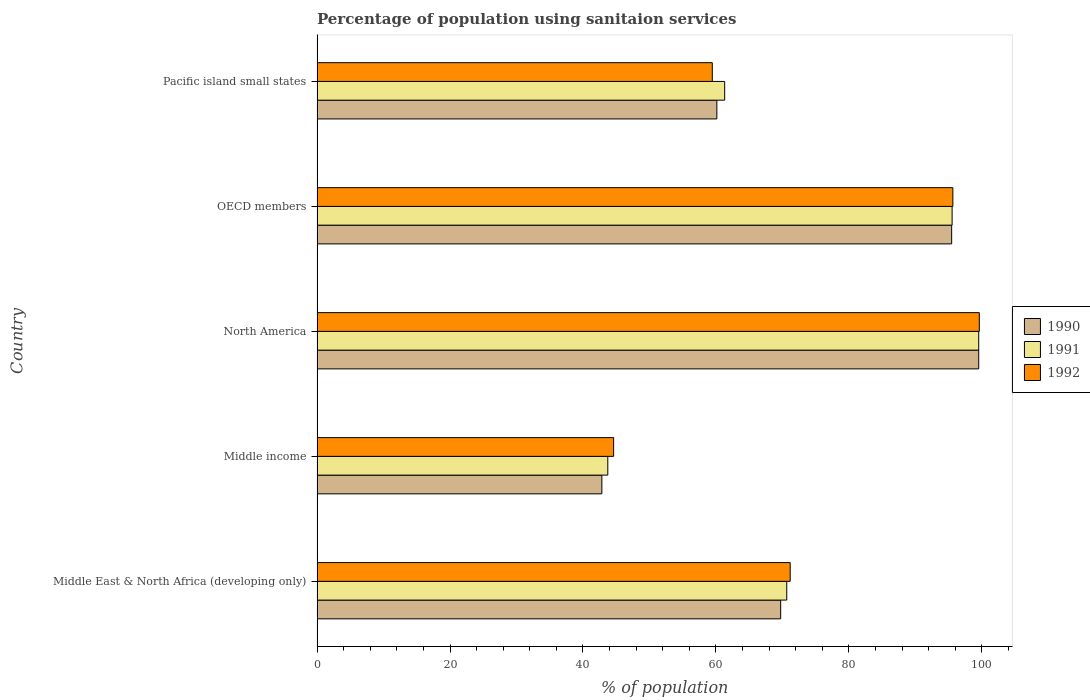How many different coloured bars are there?
Make the answer very short. 3. How many groups of bars are there?
Give a very brief answer. 5. Are the number of bars per tick equal to the number of legend labels?
Make the answer very short. Yes. How many bars are there on the 4th tick from the top?
Keep it short and to the point. 3. How many bars are there on the 4th tick from the bottom?
Your answer should be very brief. 3. What is the label of the 5th group of bars from the top?
Your response must be concise. Middle East & North Africa (developing only). In how many cases, is the number of bars for a given country not equal to the number of legend labels?
Provide a short and direct response. 0. What is the percentage of population using sanitaion services in 1991 in Middle East & North Africa (developing only)?
Your answer should be very brief. 70.65. Across all countries, what is the maximum percentage of population using sanitaion services in 1991?
Your answer should be very brief. 99.53. Across all countries, what is the minimum percentage of population using sanitaion services in 1990?
Make the answer very short. 42.84. In which country was the percentage of population using sanitaion services in 1991 maximum?
Give a very brief answer. North America. What is the total percentage of population using sanitaion services in 1992 in the graph?
Keep it short and to the point. 370.5. What is the difference between the percentage of population using sanitaion services in 1990 in Middle East & North Africa (developing only) and that in Middle income?
Offer a very short reply. 26.9. What is the difference between the percentage of population using sanitaion services in 1991 in Middle income and the percentage of population using sanitaion services in 1992 in Middle East & North Africa (developing only)?
Ensure brevity in your answer.  -27.43. What is the average percentage of population using sanitaion services in 1990 per country?
Your response must be concise. 73.54. What is the difference between the percentage of population using sanitaion services in 1992 and percentage of population using sanitaion services in 1991 in OECD members?
Provide a succinct answer. 0.11. What is the ratio of the percentage of population using sanitaion services in 1992 in Middle East & North Africa (developing only) to that in Pacific island small states?
Your response must be concise. 1.2. Is the percentage of population using sanitaion services in 1990 in OECD members less than that in Pacific island small states?
Ensure brevity in your answer.  No. Is the difference between the percentage of population using sanitaion services in 1992 in Middle income and Pacific island small states greater than the difference between the percentage of population using sanitaion services in 1991 in Middle income and Pacific island small states?
Your response must be concise. Yes. What is the difference between the highest and the second highest percentage of population using sanitaion services in 1990?
Provide a succinct answer. 4.07. What is the difference between the highest and the lowest percentage of population using sanitaion services in 1992?
Your response must be concise. 55.01. In how many countries, is the percentage of population using sanitaion services in 1992 greater than the average percentage of population using sanitaion services in 1992 taken over all countries?
Make the answer very short. 2. Is the sum of the percentage of population using sanitaion services in 1990 in Middle income and OECD members greater than the maximum percentage of population using sanitaion services in 1991 across all countries?
Provide a short and direct response. Yes. What does the 3rd bar from the top in Middle East & North Africa (developing only) represents?
Keep it short and to the point. 1990. What does the 1st bar from the bottom in OECD members represents?
Make the answer very short. 1990. Is it the case that in every country, the sum of the percentage of population using sanitaion services in 1992 and percentage of population using sanitaion services in 1991 is greater than the percentage of population using sanitaion services in 1990?
Give a very brief answer. Yes. How many bars are there?
Provide a short and direct response. 15. Are all the bars in the graph horizontal?
Provide a short and direct response. Yes. How many countries are there in the graph?
Your response must be concise. 5. What is the difference between two consecutive major ticks on the X-axis?
Your answer should be very brief. 20. Does the graph contain grids?
Provide a succinct answer. No. How are the legend labels stacked?
Provide a succinct answer. Vertical. What is the title of the graph?
Your response must be concise. Percentage of population using sanitaion services. What is the label or title of the X-axis?
Keep it short and to the point. % of population. What is the label or title of the Y-axis?
Your answer should be compact. Country. What is the % of population of 1990 in Middle East & North Africa (developing only)?
Ensure brevity in your answer.  69.74. What is the % of population in 1991 in Middle East & North Africa (developing only)?
Provide a succinct answer. 70.65. What is the % of population of 1992 in Middle East & North Africa (developing only)?
Keep it short and to the point. 71.17. What is the % of population of 1990 in Middle income?
Your answer should be very brief. 42.84. What is the % of population in 1991 in Middle income?
Keep it short and to the point. 43.74. What is the % of population of 1992 in Middle income?
Make the answer very short. 44.61. What is the % of population in 1990 in North America?
Your answer should be compact. 99.53. What is the % of population of 1991 in North America?
Keep it short and to the point. 99.53. What is the % of population of 1992 in North America?
Keep it short and to the point. 99.62. What is the % of population of 1990 in OECD members?
Keep it short and to the point. 95.46. What is the % of population in 1991 in OECD members?
Your answer should be very brief. 95.53. What is the % of population of 1992 in OECD members?
Offer a terse response. 95.64. What is the % of population of 1990 in Pacific island small states?
Your answer should be very brief. 60.14. What is the % of population of 1991 in Pacific island small states?
Provide a succinct answer. 61.32. What is the % of population of 1992 in Pacific island small states?
Your answer should be compact. 59.45. Across all countries, what is the maximum % of population in 1990?
Keep it short and to the point. 99.53. Across all countries, what is the maximum % of population of 1991?
Give a very brief answer. 99.53. Across all countries, what is the maximum % of population of 1992?
Ensure brevity in your answer.  99.62. Across all countries, what is the minimum % of population in 1990?
Offer a terse response. 42.84. Across all countries, what is the minimum % of population in 1991?
Give a very brief answer. 43.74. Across all countries, what is the minimum % of population of 1992?
Make the answer very short. 44.61. What is the total % of population in 1990 in the graph?
Your answer should be very brief. 367.71. What is the total % of population of 1991 in the graph?
Make the answer very short. 370.76. What is the total % of population of 1992 in the graph?
Provide a short and direct response. 370.5. What is the difference between the % of population of 1990 in Middle East & North Africa (developing only) and that in Middle income?
Make the answer very short. 26.9. What is the difference between the % of population of 1991 in Middle East & North Africa (developing only) and that in Middle income?
Ensure brevity in your answer.  26.92. What is the difference between the % of population in 1992 in Middle East & North Africa (developing only) and that in Middle income?
Your response must be concise. 26.56. What is the difference between the % of population in 1990 in Middle East & North Africa (developing only) and that in North America?
Your answer should be compact. -29.79. What is the difference between the % of population in 1991 in Middle East & North Africa (developing only) and that in North America?
Provide a succinct answer. -28.88. What is the difference between the % of population of 1992 in Middle East & North Africa (developing only) and that in North America?
Offer a terse response. -28.45. What is the difference between the % of population in 1990 in Middle East & North Africa (developing only) and that in OECD members?
Your answer should be compact. -25.72. What is the difference between the % of population of 1991 in Middle East & North Africa (developing only) and that in OECD members?
Provide a short and direct response. -24.87. What is the difference between the % of population of 1992 in Middle East & North Africa (developing only) and that in OECD members?
Ensure brevity in your answer.  -24.47. What is the difference between the % of population of 1990 in Middle East & North Africa (developing only) and that in Pacific island small states?
Ensure brevity in your answer.  9.6. What is the difference between the % of population in 1991 in Middle East & North Africa (developing only) and that in Pacific island small states?
Ensure brevity in your answer.  9.34. What is the difference between the % of population of 1992 in Middle East & North Africa (developing only) and that in Pacific island small states?
Ensure brevity in your answer.  11.72. What is the difference between the % of population in 1990 in Middle income and that in North America?
Offer a very short reply. -56.69. What is the difference between the % of population of 1991 in Middle income and that in North America?
Your response must be concise. -55.79. What is the difference between the % of population of 1992 in Middle income and that in North America?
Your response must be concise. -55.01. What is the difference between the % of population in 1990 in Middle income and that in OECD members?
Give a very brief answer. -52.62. What is the difference between the % of population of 1991 in Middle income and that in OECD members?
Offer a terse response. -51.79. What is the difference between the % of population of 1992 in Middle income and that in OECD members?
Your response must be concise. -51.03. What is the difference between the % of population in 1990 in Middle income and that in Pacific island small states?
Provide a succinct answer. -17.3. What is the difference between the % of population of 1991 in Middle income and that in Pacific island small states?
Give a very brief answer. -17.58. What is the difference between the % of population in 1992 in Middle income and that in Pacific island small states?
Give a very brief answer. -14.84. What is the difference between the % of population in 1990 in North America and that in OECD members?
Provide a succinct answer. 4.07. What is the difference between the % of population of 1991 in North America and that in OECD members?
Offer a very short reply. 4. What is the difference between the % of population of 1992 in North America and that in OECD members?
Offer a terse response. 3.98. What is the difference between the % of population in 1990 in North America and that in Pacific island small states?
Your answer should be compact. 39.39. What is the difference between the % of population in 1991 in North America and that in Pacific island small states?
Your response must be concise. 38.21. What is the difference between the % of population in 1992 in North America and that in Pacific island small states?
Make the answer very short. 40.17. What is the difference between the % of population in 1990 in OECD members and that in Pacific island small states?
Keep it short and to the point. 35.32. What is the difference between the % of population of 1991 in OECD members and that in Pacific island small states?
Your response must be concise. 34.21. What is the difference between the % of population in 1992 in OECD members and that in Pacific island small states?
Your response must be concise. 36.19. What is the difference between the % of population in 1990 in Middle East & North Africa (developing only) and the % of population in 1991 in Middle income?
Make the answer very short. 26. What is the difference between the % of population in 1990 in Middle East & North Africa (developing only) and the % of population in 1992 in Middle income?
Provide a succinct answer. 25.13. What is the difference between the % of population in 1991 in Middle East & North Africa (developing only) and the % of population in 1992 in Middle income?
Provide a short and direct response. 26.04. What is the difference between the % of population of 1990 in Middle East & North Africa (developing only) and the % of population of 1991 in North America?
Keep it short and to the point. -29.79. What is the difference between the % of population of 1990 in Middle East & North Africa (developing only) and the % of population of 1992 in North America?
Provide a short and direct response. -29.88. What is the difference between the % of population in 1991 in Middle East & North Africa (developing only) and the % of population in 1992 in North America?
Your answer should be very brief. -28.97. What is the difference between the % of population in 1990 in Middle East & North Africa (developing only) and the % of population in 1991 in OECD members?
Your answer should be compact. -25.79. What is the difference between the % of population of 1990 in Middle East & North Africa (developing only) and the % of population of 1992 in OECD members?
Your response must be concise. -25.9. What is the difference between the % of population in 1991 in Middle East & North Africa (developing only) and the % of population in 1992 in OECD members?
Provide a succinct answer. -24.99. What is the difference between the % of population of 1990 in Middle East & North Africa (developing only) and the % of population of 1991 in Pacific island small states?
Give a very brief answer. 8.42. What is the difference between the % of population in 1990 in Middle East & North Africa (developing only) and the % of population in 1992 in Pacific island small states?
Provide a succinct answer. 10.29. What is the difference between the % of population in 1991 in Middle East & North Africa (developing only) and the % of population in 1992 in Pacific island small states?
Your response must be concise. 11.2. What is the difference between the % of population in 1990 in Middle income and the % of population in 1991 in North America?
Provide a short and direct response. -56.69. What is the difference between the % of population in 1990 in Middle income and the % of population in 1992 in North America?
Your answer should be very brief. -56.78. What is the difference between the % of population in 1991 in Middle income and the % of population in 1992 in North America?
Make the answer very short. -55.88. What is the difference between the % of population in 1990 in Middle income and the % of population in 1991 in OECD members?
Make the answer very short. -52.69. What is the difference between the % of population of 1990 in Middle income and the % of population of 1992 in OECD members?
Your answer should be compact. -52.8. What is the difference between the % of population of 1991 in Middle income and the % of population of 1992 in OECD members?
Your response must be concise. -51.9. What is the difference between the % of population of 1990 in Middle income and the % of population of 1991 in Pacific island small states?
Ensure brevity in your answer.  -18.47. What is the difference between the % of population in 1990 in Middle income and the % of population in 1992 in Pacific island small states?
Your answer should be compact. -16.61. What is the difference between the % of population of 1991 in Middle income and the % of population of 1992 in Pacific island small states?
Give a very brief answer. -15.72. What is the difference between the % of population of 1990 in North America and the % of population of 1991 in OECD members?
Provide a succinct answer. 4. What is the difference between the % of population of 1990 in North America and the % of population of 1992 in OECD members?
Offer a very short reply. 3.89. What is the difference between the % of population in 1991 in North America and the % of population in 1992 in OECD members?
Offer a terse response. 3.89. What is the difference between the % of population in 1990 in North America and the % of population in 1991 in Pacific island small states?
Keep it short and to the point. 38.21. What is the difference between the % of population of 1990 in North America and the % of population of 1992 in Pacific island small states?
Ensure brevity in your answer.  40.08. What is the difference between the % of population in 1991 in North America and the % of population in 1992 in Pacific island small states?
Your response must be concise. 40.08. What is the difference between the % of population of 1990 in OECD members and the % of population of 1991 in Pacific island small states?
Your answer should be very brief. 34.14. What is the difference between the % of population in 1990 in OECD members and the % of population in 1992 in Pacific island small states?
Your answer should be compact. 36.01. What is the difference between the % of population in 1991 in OECD members and the % of population in 1992 in Pacific island small states?
Your answer should be compact. 36.07. What is the average % of population in 1990 per country?
Make the answer very short. 73.54. What is the average % of population in 1991 per country?
Offer a terse response. 74.15. What is the average % of population in 1992 per country?
Give a very brief answer. 74.1. What is the difference between the % of population of 1990 and % of population of 1991 in Middle East & North Africa (developing only)?
Your answer should be very brief. -0.91. What is the difference between the % of population of 1990 and % of population of 1992 in Middle East & North Africa (developing only)?
Your answer should be very brief. -1.43. What is the difference between the % of population in 1991 and % of population in 1992 in Middle East & North Africa (developing only)?
Provide a short and direct response. -0.52. What is the difference between the % of population in 1990 and % of population in 1991 in Middle income?
Offer a very short reply. -0.89. What is the difference between the % of population in 1990 and % of population in 1992 in Middle income?
Your response must be concise. -1.77. What is the difference between the % of population of 1991 and % of population of 1992 in Middle income?
Your response must be concise. -0.88. What is the difference between the % of population of 1990 and % of population of 1991 in North America?
Your answer should be very brief. -0. What is the difference between the % of population of 1990 and % of population of 1992 in North America?
Your answer should be compact. -0.09. What is the difference between the % of population in 1991 and % of population in 1992 in North America?
Give a very brief answer. -0.09. What is the difference between the % of population in 1990 and % of population in 1991 in OECD members?
Provide a short and direct response. -0.07. What is the difference between the % of population of 1990 and % of population of 1992 in OECD members?
Your response must be concise. -0.18. What is the difference between the % of population in 1991 and % of population in 1992 in OECD members?
Offer a very short reply. -0.11. What is the difference between the % of population in 1990 and % of population in 1991 in Pacific island small states?
Make the answer very short. -1.18. What is the difference between the % of population of 1990 and % of population of 1992 in Pacific island small states?
Offer a terse response. 0.69. What is the difference between the % of population of 1991 and % of population of 1992 in Pacific island small states?
Your response must be concise. 1.86. What is the ratio of the % of population of 1990 in Middle East & North Africa (developing only) to that in Middle income?
Your answer should be compact. 1.63. What is the ratio of the % of population of 1991 in Middle East & North Africa (developing only) to that in Middle income?
Provide a succinct answer. 1.62. What is the ratio of the % of population of 1992 in Middle East & North Africa (developing only) to that in Middle income?
Offer a terse response. 1.6. What is the ratio of the % of population of 1990 in Middle East & North Africa (developing only) to that in North America?
Offer a very short reply. 0.7. What is the ratio of the % of population of 1991 in Middle East & North Africa (developing only) to that in North America?
Your answer should be compact. 0.71. What is the ratio of the % of population in 1992 in Middle East & North Africa (developing only) to that in North America?
Provide a succinct answer. 0.71. What is the ratio of the % of population in 1990 in Middle East & North Africa (developing only) to that in OECD members?
Your answer should be very brief. 0.73. What is the ratio of the % of population of 1991 in Middle East & North Africa (developing only) to that in OECD members?
Your answer should be compact. 0.74. What is the ratio of the % of population of 1992 in Middle East & North Africa (developing only) to that in OECD members?
Your response must be concise. 0.74. What is the ratio of the % of population in 1990 in Middle East & North Africa (developing only) to that in Pacific island small states?
Make the answer very short. 1.16. What is the ratio of the % of population of 1991 in Middle East & North Africa (developing only) to that in Pacific island small states?
Offer a very short reply. 1.15. What is the ratio of the % of population in 1992 in Middle East & North Africa (developing only) to that in Pacific island small states?
Your answer should be very brief. 1.2. What is the ratio of the % of population in 1990 in Middle income to that in North America?
Keep it short and to the point. 0.43. What is the ratio of the % of population of 1991 in Middle income to that in North America?
Keep it short and to the point. 0.44. What is the ratio of the % of population of 1992 in Middle income to that in North America?
Your response must be concise. 0.45. What is the ratio of the % of population in 1990 in Middle income to that in OECD members?
Offer a very short reply. 0.45. What is the ratio of the % of population of 1991 in Middle income to that in OECD members?
Keep it short and to the point. 0.46. What is the ratio of the % of population in 1992 in Middle income to that in OECD members?
Offer a terse response. 0.47. What is the ratio of the % of population of 1990 in Middle income to that in Pacific island small states?
Provide a short and direct response. 0.71. What is the ratio of the % of population in 1991 in Middle income to that in Pacific island small states?
Keep it short and to the point. 0.71. What is the ratio of the % of population of 1992 in Middle income to that in Pacific island small states?
Make the answer very short. 0.75. What is the ratio of the % of population of 1990 in North America to that in OECD members?
Ensure brevity in your answer.  1.04. What is the ratio of the % of population in 1991 in North America to that in OECD members?
Your answer should be very brief. 1.04. What is the ratio of the % of population of 1992 in North America to that in OECD members?
Ensure brevity in your answer.  1.04. What is the ratio of the % of population in 1990 in North America to that in Pacific island small states?
Your response must be concise. 1.66. What is the ratio of the % of population in 1991 in North America to that in Pacific island small states?
Your response must be concise. 1.62. What is the ratio of the % of population in 1992 in North America to that in Pacific island small states?
Offer a terse response. 1.68. What is the ratio of the % of population of 1990 in OECD members to that in Pacific island small states?
Offer a terse response. 1.59. What is the ratio of the % of population of 1991 in OECD members to that in Pacific island small states?
Your answer should be very brief. 1.56. What is the ratio of the % of population of 1992 in OECD members to that in Pacific island small states?
Keep it short and to the point. 1.61. What is the difference between the highest and the second highest % of population in 1990?
Keep it short and to the point. 4.07. What is the difference between the highest and the second highest % of population in 1991?
Provide a succinct answer. 4. What is the difference between the highest and the second highest % of population of 1992?
Provide a short and direct response. 3.98. What is the difference between the highest and the lowest % of population of 1990?
Your response must be concise. 56.69. What is the difference between the highest and the lowest % of population in 1991?
Keep it short and to the point. 55.79. What is the difference between the highest and the lowest % of population of 1992?
Provide a succinct answer. 55.01. 